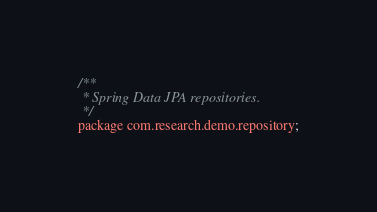<code> <loc_0><loc_0><loc_500><loc_500><_Java_>/**
 * Spring Data JPA repositories.
 */
package com.research.demo.repository;
</code> 